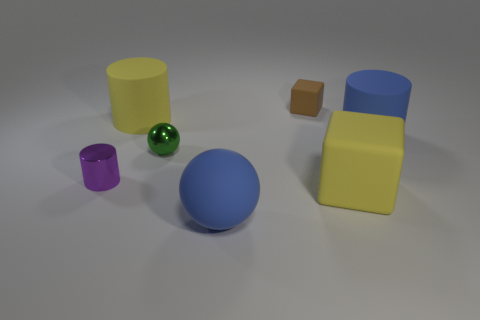Add 2 tiny matte cubes. How many objects exist? 9 Subtract all balls. How many objects are left? 5 Add 1 big yellow blocks. How many big yellow blocks are left? 2 Add 6 brown matte blocks. How many brown matte blocks exist? 7 Subtract 0 purple spheres. How many objects are left? 7 Subtract all brown things. Subtract all small balls. How many objects are left? 5 